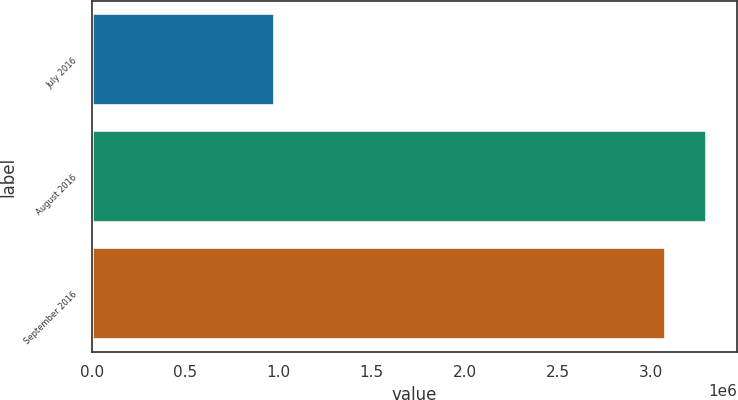<chart> <loc_0><loc_0><loc_500><loc_500><bar_chart><fcel>July 2016<fcel>August 2016<fcel>September 2016<nl><fcel>979592<fcel>3.29635e+06<fcel>3.08053e+06<nl></chart> 